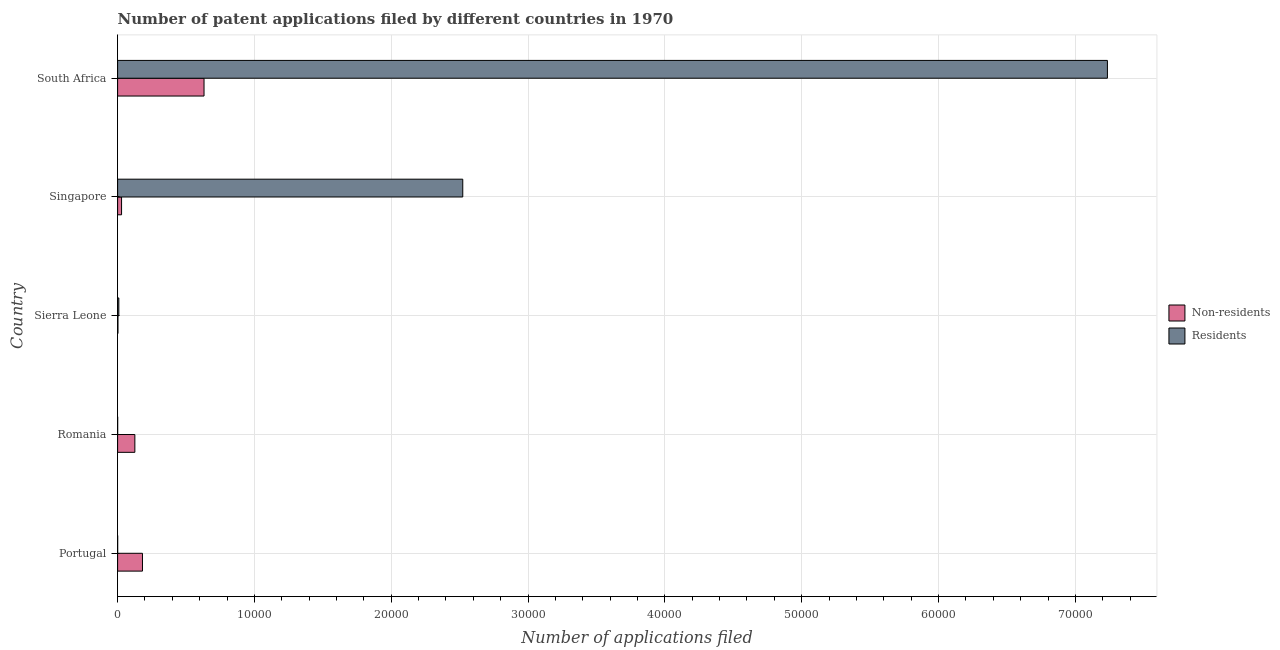How many groups of bars are there?
Provide a succinct answer. 5. Are the number of bars on each tick of the Y-axis equal?
Provide a succinct answer. Yes. What is the label of the 5th group of bars from the top?
Provide a succinct answer. Portugal. What is the number of patent applications by non residents in Singapore?
Provide a succinct answer. 289. Across all countries, what is the maximum number of patent applications by residents?
Offer a very short reply. 7.23e+04. Across all countries, what is the minimum number of patent applications by non residents?
Your answer should be very brief. 25. In which country was the number of patent applications by residents maximum?
Keep it short and to the point. South Africa. In which country was the number of patent applications by non residents minimum?
Provide a succinct answer. Sierra Leone. What is the total number of patent applications by non residents in the graph?
Your answer should be very brief. 9708. What is the difference between the number of patent applications by non residents in Portugal and that in Romania?
Give a very brief answer. 556. What is the difference between the number of patent applications by non residents in Sierra Leone and the number of patent applications by residents in Singapore?
Provide a succinct answer. -2.52e+04. What is the average number of patent applications by non residents per country?
Offer a very short reply. 1941.6. What is the difference between the number of patent applications by non residents and number of patent applications by residents in South Africa?
Provide a succinct answer. -6.60e+04. In how many countries, is the number of patent applications by non residents greater than 10000 ?
Keep it short and to the point. 0. What is the ratio of the number of patent applications by non residents in Singapore to that in South Africa?
Offer a very short reply. 0.05. What is the difference between the highest and the second highest number of patent applications by residents?
Your answer should be very brief. 4.71e+04. What is the difference between the highest and the lowest number of patent applications by residents?
Offer a terse response. 7.23e+04. In how many countries, is the number of patent applications by residents greater than the average number of patent applications by residents taken over all countries?
Give a very brief answer. 2. What does the 2nd bar from the top in Portugal represents?
Your answer should be very brief. Non-residents. What does the 1st bar from the bottom in South Africa represents?
Offer a terse response. Non-residents. How many bars are there?
Make the answer very short. 10. How many countries are there in the graph?
Your answer should be compact. 5. Does the graph contain any zero values?
Ensure brevity in your answer.  No. Does the graph contain grids?
Make the answer very short. Yes. Where does the legend appear in the graph?
Keep it short and to the point. Center right. How many legend labels are there?
Provide a short and direct response. 2. What is the title of the graph?
Offer a very short reply. Number of patent applications filed by different countries in 1970. What is the label or title of the X-axis?
Your answer should be very brief. Number of applications filed. What is the label or title of the Y-axis?
Make the answer very short. Country. What is the Number of applications filed of Non-residents in Portugal?
Your response must be concise. 1817. What is the Number of applications filed of Residents in Portugal?
Your response must be concise. 4. What is the Number of applications filed of Non-residents in Romania?
Ensure brevity in your answer.  1261. What is the Number of applications filed of Residents in Sierra Leone?
Keep it short and to the point. 89. What is the Number of applications filed of Non-residents in Singapore?
Keep it short and to the point. 289. What is the Number of applications filed in Residents in Singapore?
Your answer should be very brief. 2.52e+04. What is the Number of applications filed in Non-residents in South Africa?
Your response must be concise. 6316. What is the Number of applications filed in Residents in South Africa?
Offer a terse response. 7.23e+04. Across all countries, what is the maximum Number of applications filed in Non-residents?
Offer a terse response. 6316. Across all countries, what is the maximum Number of applications filed of Residents?
Make the answer very short. 7.23e+04. What is the total Number of applications filed in Non-residents in the graph?
Offer a very short reply. 9708. What is the total Number of applications filed of Residents in the graph?
Offer a very short reply. 9.77e+04. What is the difference between the Number of applications filed in Non-residents in Portugal and that in Romania?
Ensure brevity in your answer.  556. What is the difference between the Number of applications filed of Residents in Portugal and that in Romania?
Provide a short and direct response. 1. What is the difference between the Number of applications filed in Non-residents in Portugal and that in Sierra Leone?
Ensure brevity in your answer.  1792. What is the difference between the Number of applications filed of Residents in Portugal and that in Sierra Leone?
Ensure brevity in your answer.  -85. What is the difference between the Number of applications filed of Non-residents in Portugal and that in Singapore?
Your answer should be very brief. 1528. What is the difference between the Number of applications filed in Residents in Portugal and that in Singapore?
Your answer should be compact. -2.52e+04. What is the difference between the Number of applications filed of Non-residents in Portugal and that in South Africa?
Give a very brief answer. -4499. What is the difference between the Number of applications filed in Residents in Portugal and that in South Africa?
Offer a very short reply. -7.23e+04. What is the difference between the Number of applications filed of Non-residents in Romania and that in Sierra Leone?
Offer a very short reply. 1236. What is the difference between the Number of applications filed of Residents in Romania and that in Sierra Leone?
Make the answer very short. -86. What is the difference between the Number of applications filed of Non-residents in Romania and that in Singapore?
Make the answer very short. 972. What is the difference between the Number of applications filed of Residents in Romania and that in Singapore?
Make the answer very short. -2.52e+04. What is the difference between the Number of applications filed of Non-residents in Romania and that in South Africa?
Give a very brief answer. -5055. What is the difference between the Number of applications filed of Residents in Romania and that in South Africa?
Make the answer very short. -7.23e+04. What is the difference between the Number of applications filed in Non-residents in Sierra Leone and that in Singapore?
Offer a very short reply. -264. What is the difference between the Number of applications filed of Residents in Sierra Leone and that in Singapore?
Your response must be concise. -2.51e+04. What is the difference between the Number of applications filed of Non-residents in Sierra Leone and that in South Africa?
Offer a very short reply. -6291. What is the difference between the Number of applications filed in Residents in Sierra Leone and that in South Africa?
Your answer should be compact. -7.23e+04. What is the difference between the Number of applications filed of Non-residents in Singapore and that in South Africa?
Keep it short and to the point. -6027. What is the difference between the Number of applications filed of Residents in Singapore and that in South Africa?
Provide a short and direct response. -4.71e+04. What is the difference between the Number of applications filed of Non-residents in Portugal and the Number of applications filed of Residents in Romania?
Offer a very short reply. 1814. What is the difference between the Number of applications filed in Non-residents in Portugal and the Number of applications filed in Residents in Sierra Leone?
Provide a short and direct response. 1728. What is the difference between the Number of applications filed of Non-residents in Portugal and the Number of applications filed of Residents in Singapore?
Offer a terse response. -2.34e+04. What is the difference between the Number of applications filed of Non-residents in Portugal and the Number of applications filed of Residents in South Africa?
Your response must be concise. -7.05e+04. What is the difference between the Number of applications filed of Non-residents in Romania and the Number of applications filed of Residents in Sierra Leone?
Offer a terse response. 1172. What is the difference between the Number of applications filed in Non-residents in Romania and the Number of applications filed in Residents in Singapore?
Offer a terse response. -2.40e+04. What is the difference between the Number of applications filed in Non-residents in Romania and the Number of applications filed in Residents in South Africa?
Provide a short and direct response. -7.11e+04. What is the difference between the Number of applications filed in Non-residents in Sierra Leone and the Number of applications filed in Residents in Singapore?
Give a very brief answer. -2.52e+04. What is the difference between the Number of applications filed in Non-residents in Sierra Leone and the Number of applications filed in Residents in South Africa?
Offer a very short reply. -7.23e+04. What is the difference between the Number of applications filed in Non-residents in Singapore and the Number of applications filed in Residents in South Africa?
Ensure brevity in your answer.  -7.21e+04. What is the average Number of applications filed of Non-residents per country?
Give a very brief answer. 1941.6. What is the average Number of applications filed of Residents per country?
Offer a terse response. 1.95e+04. What is the difference between the Number of applications filed in Non-residents and Number of applications filed in Residents in Portugal?
Provide a short and direct response. 1813. What is the difference between the Number of applications filed of Non-residents and Number of applications filed of Residents in Romania?
Ensure brevity in your answer.  1258. What is the difference between the Number of applications filed in Non-residents and Number of applications filed in Residents in Sierra Leone?
Provide a short and direct response. -64. What is the difference between the Number of applications filed in Non-residents and Number of applications filed in Residents in Singapore?
Offer a terse response. -2.49e+04. What is the difference between the Number of applications filed of Non-residents and Number of applications filed of Residents in South Africa?
Give a very brief answer. -6.60e+04. What is the ratio of the Number of applications filed of Non-residents in Portugal to that in Romania?
Provide a succinct answer. 1.44. What is the ratio of the Number of applications filed in Residents in Portugal to that in Romania?
Make the answer very short. 1.33. What is the ratio of the Number of applications filed of Non-residents in Portugal to that in Sierra Leone?
Offer a terse response. 72.68. What is the ratio of the Number of applications filed in Residents in Portugal to that in Sierra Leone?
Offer a terse response. 0.04. What is the ratio of the Number of applications filed of Non-residents in Portugal to that in Singapore?
Offer a terse response. 6.29. What is the ratio of the Number of applications filed of Non-residents in Portugal to that in South Africa?
Keep it short and to the point. 0.29. What is the ratio of the Number of applications filed of Residents in Portugal to that in South Africa?
Your answer should be compact. 0. What is the ratio of the Number of applications filed of Non-residents in Romania to that in Sierra Leone?
Provide a short and direct response. 50.44. What is the ratio of the Number of applications filed in Residents in Romania to that in Sierra Leone?
Give a very brief answer. 0.03. What is the ratio of the Number of applications filed of Non-residents in Romania to that in Singapore?
Offer a very short reply. 4.36. What is the ratio of the Number of applications filed in Residents in Romania to that in Singapore?
Give a very brief answer. 0. What is the ratio of the Number of applications filed of Non-residents in Romania to that in South Africa?
Offer a very short reply. 0.2. What is the ratio of the Number of applications filed in Non-residents in Sierra Leone to that in Singapore?
Keep it short and to the point. 0.09. What is the ratio of the Number of applications filed of Residents in Sierra Leone to that in Singapore?
Keep it short and to the point. 0. What is the ratio of the Number of applications filed of Non-residents in Sierra Leone to that in South Africa?
Give a very brief answer. 0. What is the ratio of the Number of applications filed of Residents in Sierra Leone to that in South Africa?
Your answer should be compact. 0. What is the ratio of the Number of applications filed of Non-residents in Singapore to that in South Africa?
Your answer should be very brief. 0.05. What is the ratio of the Number of applications filed of Residents in Singapore to that in South Africa?
Make the answer very short. 0.35. What is the difference between the highest and the second highest Number of applications filed of Non-residents?
Make the answer very short. 4499. What is the difference between the highest and the second highest Number of applications filed of Residents?
Your answer should be very brief. 4.71e+04. What is the difference between the highest and the lowest Number of applications filed of Non-residents?
Offer a terse response. 6291. What is the difference between the highest and the lowest Number of applications filed of Residents?
Make the answer very short. 7.23e+04. 